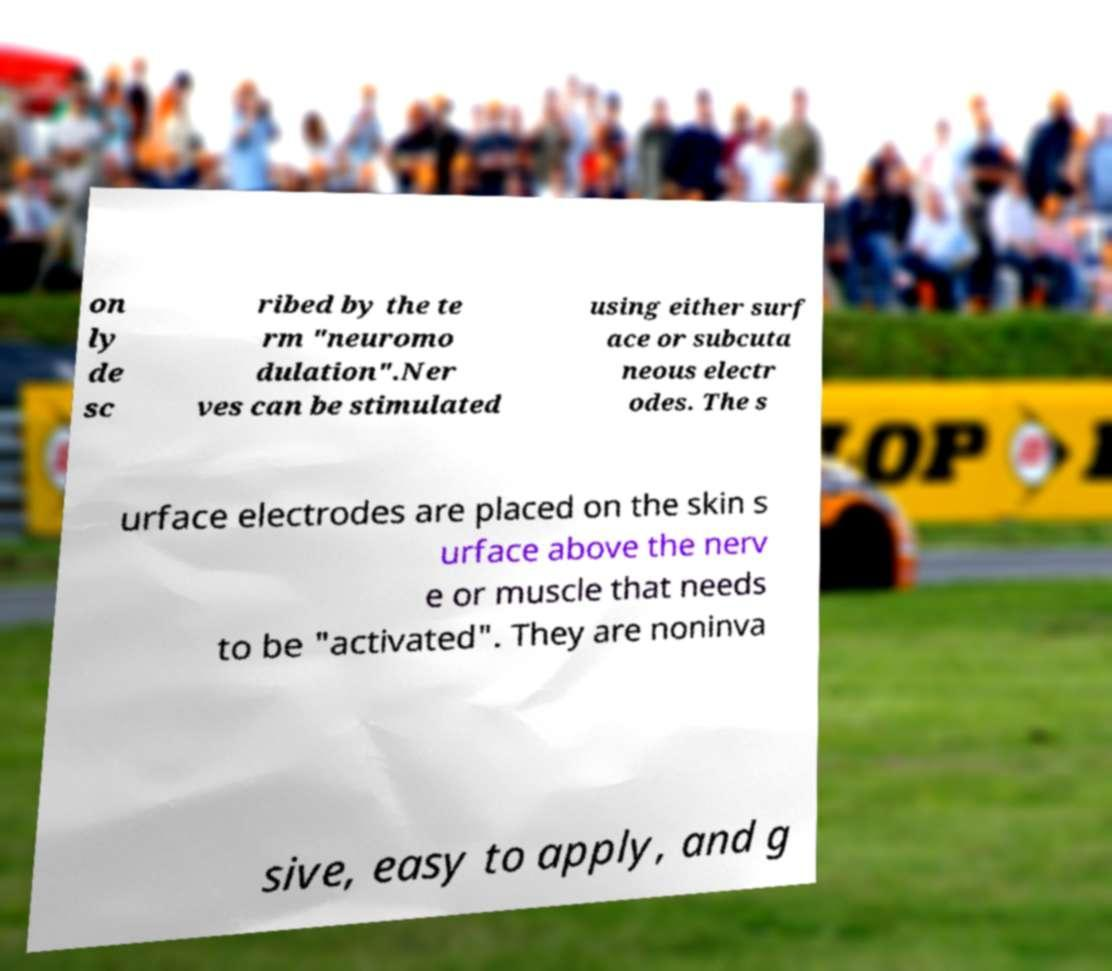Please read and relay the text visible in this image. What does it say? on ly de sc ribed by the te rm "neuromo dulation".Ner ves can be stimulated using either surf ace or subcuta neous electr odes. The s urface electrodes are placed on the skin s urface above the nerv e or muscle that needs to be "activated". They are noninva sive, easy to apply, and g 